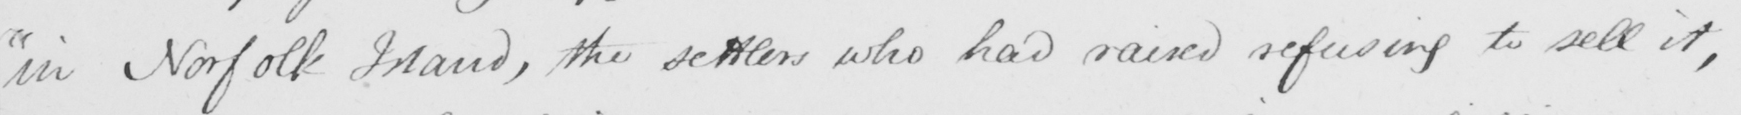Can you tell me what this handwritten text says? "in Norfolk Island, the settlers who had raised refusing to sell it, 